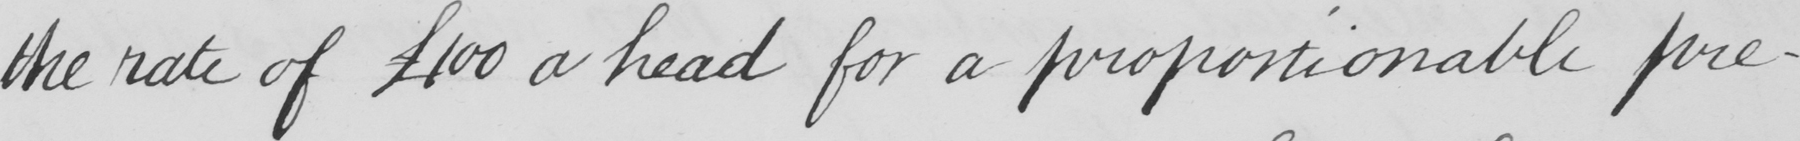Can you tell me what this handwritten text says? the rate of  £100 a head for a proportionable pre- 